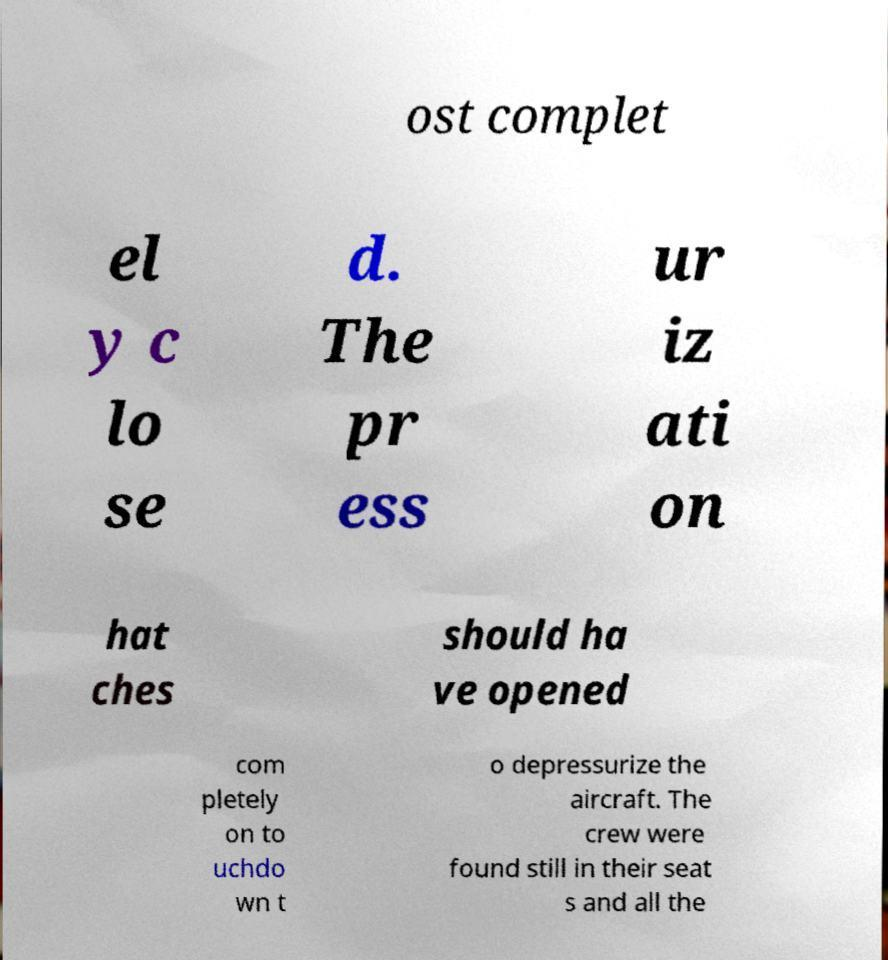What messages or text are displayed in this image? I need them in a readable, typed format. ost complet el y c lo se d. The pr ess ur iz ati on hat ches should ha ve opened com pletely on to uchdo wn t o depressurize the aircraft. The crew were found still in their seat s and all the 